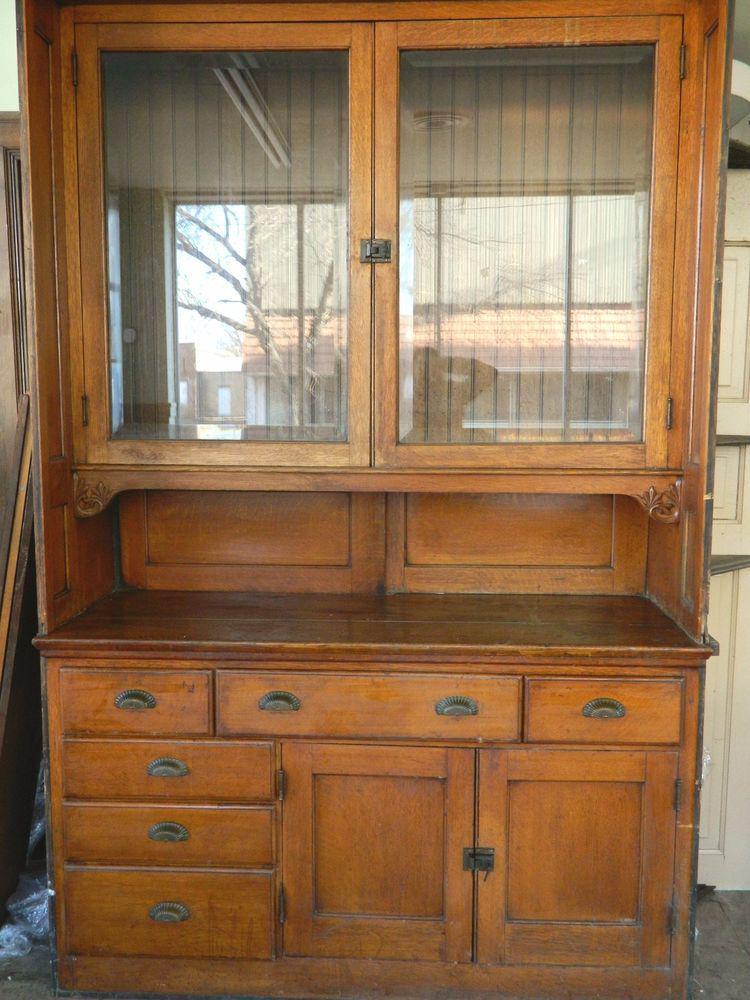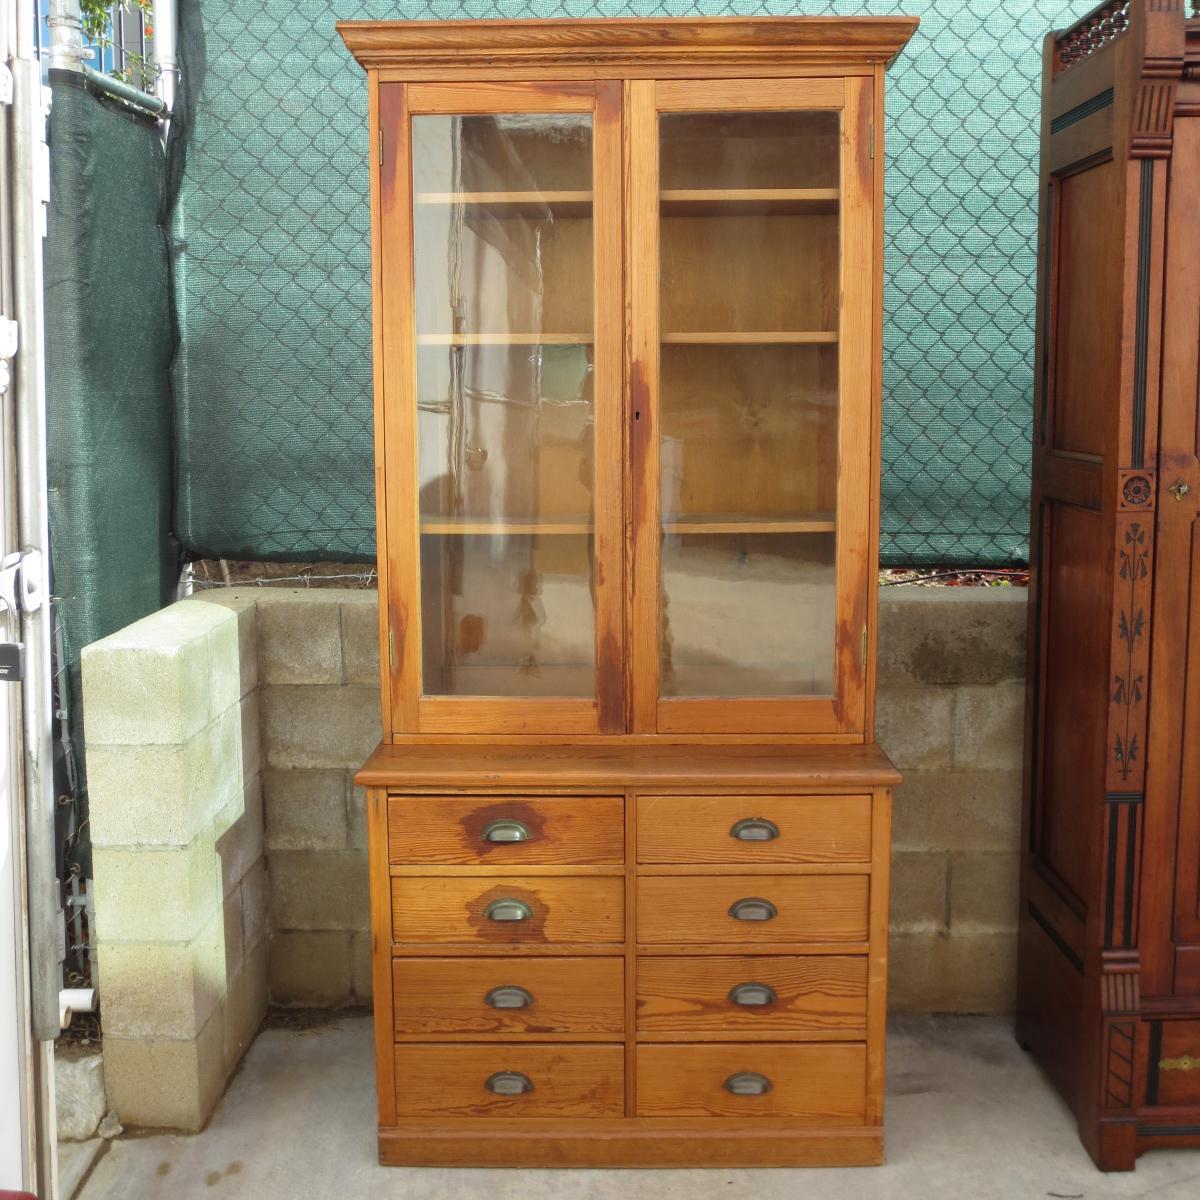The first image is the image on the left, the second image is the image on the right. Given the left and right images, does the statement "There are two glass doors in the image on the left." hold true? Answer yes or no. Yes. The first image is the image on the left, the second image is the image on the right. Examine the images to the left and right. Is the description "Each image shows an empty rectangular hutch with glass upper cabinet doors." accurate? Answer yes or no. Yes. 